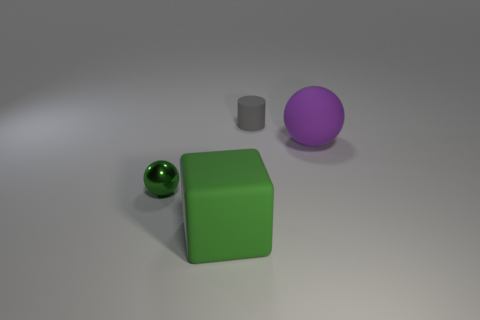What number of objects are in front of the tiny thing that is on the left side of the big matte thing that is on the left side of the purple rubber object?
Provide a succinct answer. 1. There is a green thing that is behind the big green rubber thing; does it have the same shape as the purple matte object?
Offer a very short reply. Yes. There is a tiny object that is in front of the gray matte thing; is there a gray rubber cylinder that is left of it?
Your answer should be compact. No. What number of large purple rubber things are there?
Offer a terse response. 1. There is a matte thing that is behind the large green cube and in front of the small matte cylinder; what is its color?
Offer a very short reply. Purple. What size is the other thing that is the same shape as the shiny thing?
Keep it short and to the point. Large. What number of yellow objects have the same size as the rubber block?
Provide a short and direct response. 0. What material is the block?
Provide a succinct answer. Rubber. Are there any small rubber cylinders on the right side of the large purple matte object?
Keep it short and to the point. No. There is a gray cylinder that is the same material as the purple object; what size is it?
Provide a succinct answer. Small. 